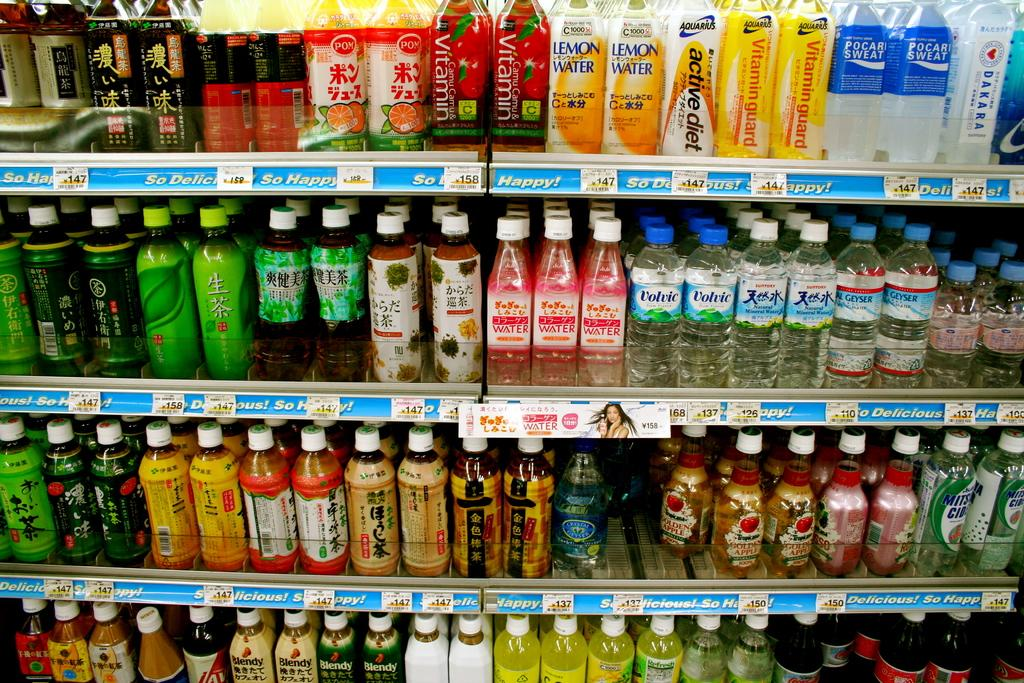What is the main feature of the image? The main feature of the image is the presence of many racks. What can be found on the racks? Different varieties of bottles are kept on the racks. How can the contents of the bottles be identified? There are labels on the bottles. What type of nut is stored in the library in the image? There is no nut or library present in the image; it features racks with bottles and labels. 